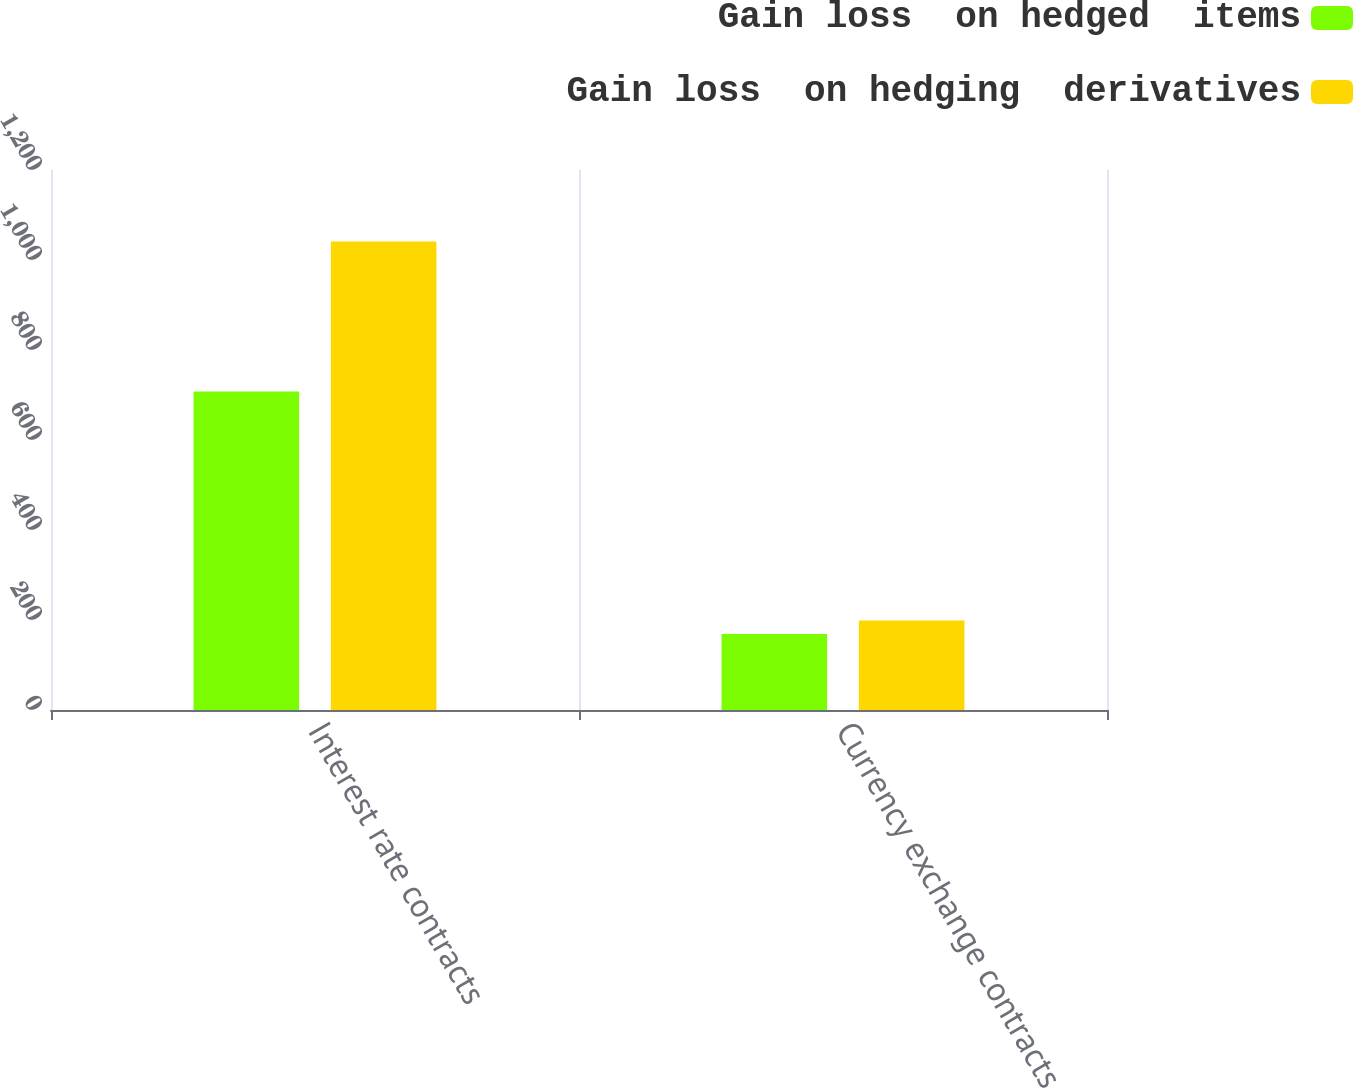Convert chart to OTSL. <chart><loc_0><loc_0><loc_500><loc_500><stacked_bar_chart><ecel><fcel>Interest rate contracts<fcel>Currency exchange contracts<nl><fcel>Gain loss  on hedged  items<fcel>708<fcel>169<nl><fcel>Gain loss  on hedging  derivatives<fcel>1041<fcel>199<nl></chart> 